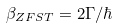<formula> <loc_0><loc_0><loc_500><loc_500>\beta _ { Z F S T } = 2 \Gamma / \hbar</formula> 